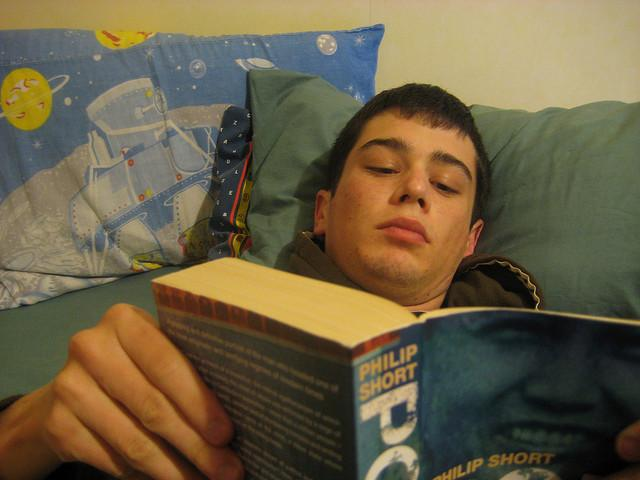What is the boy doing with the book? Please explain your reasoning. reading it. You can tell by his position with the book as to what he is doing with it. 